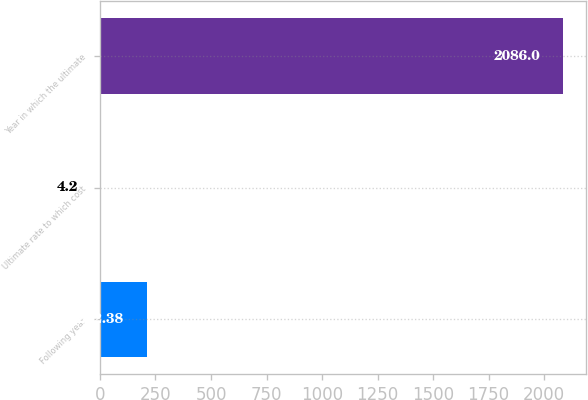<chart> <loc_0><loc_0><loc_500><loc_500><bar_chart><fcel>Following year<fcel>Ultimate rate to which cost<fcel>Year in which the ultimate<nl><fcel>212.38<fcel>4.2<fcel>2086<nl></chart> 